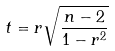<formula> <loc_0><loc_0><loc_500><loc_500>t = r \sqrt { \frac { n - 2 } { 1 - r ^ { 2 } } }</formula> 